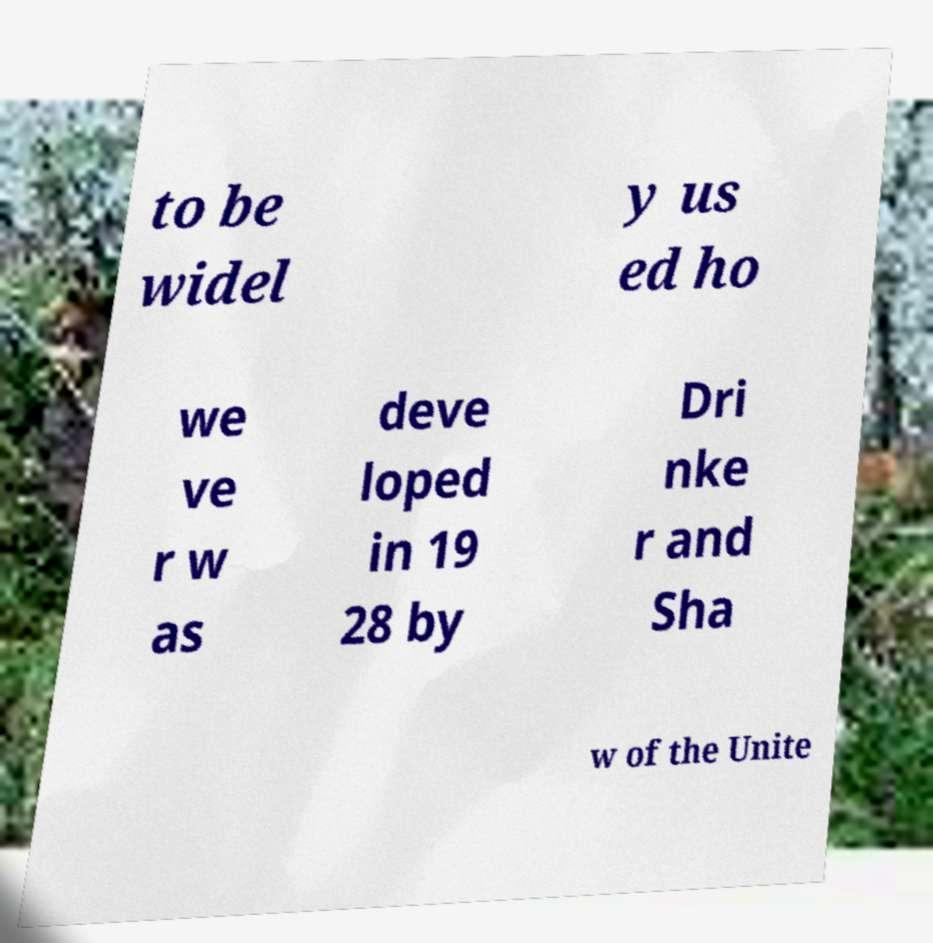There's text embedded in this image that I need extracted. Can you transcribe it verbatim? to be widel y us ed ho we ve r w as deve loped in 19 28 by Dri nke r and Sha w of the Unite 